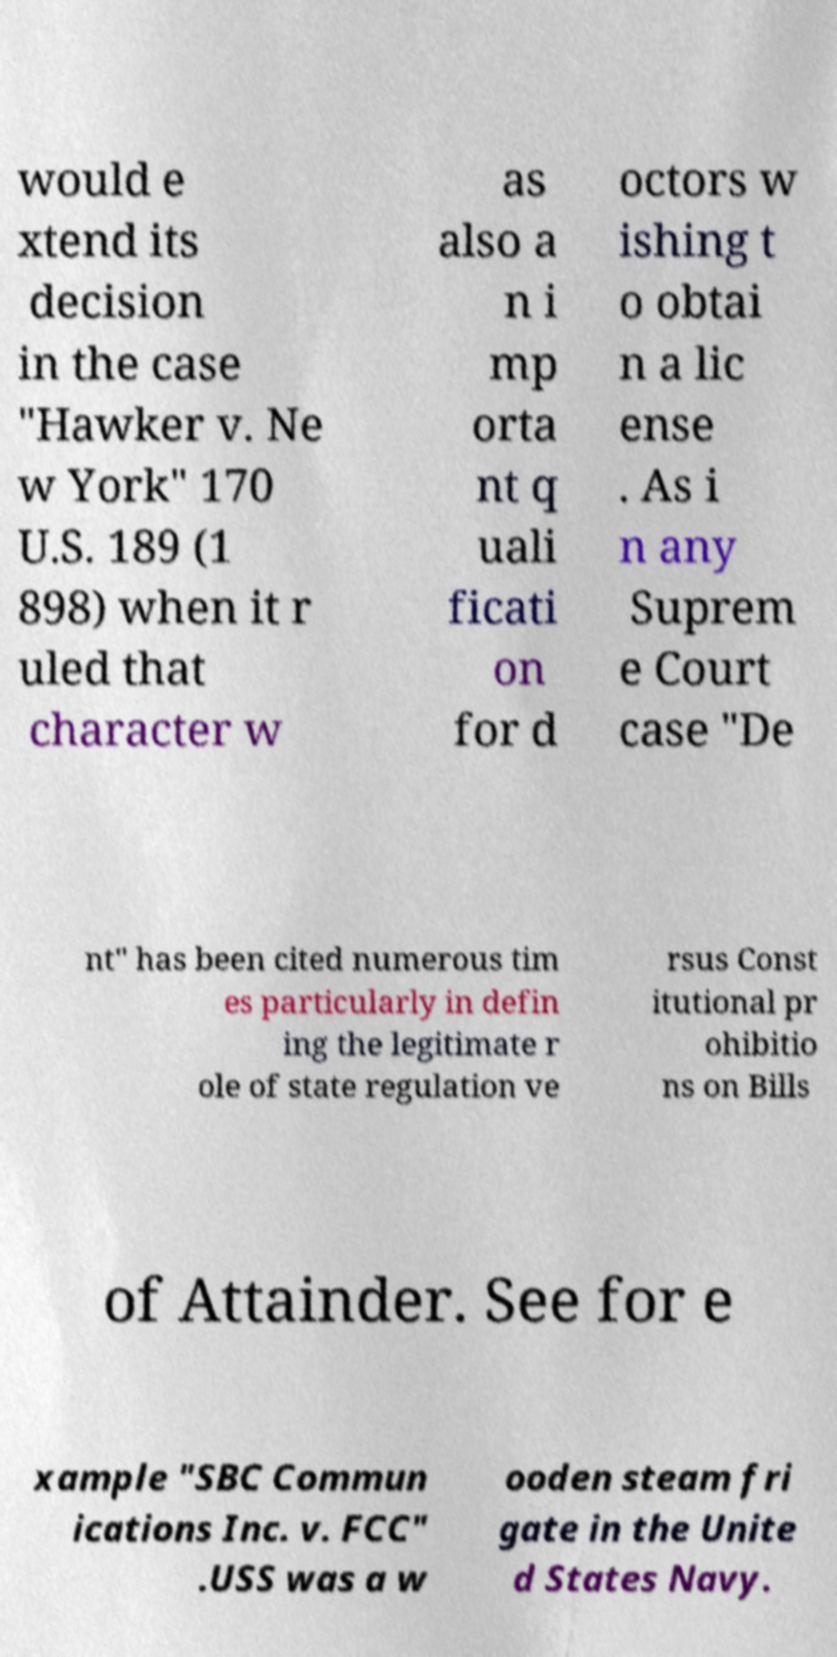Please read and relay the text visible in this image. What does it say? would e xtend its decision in the case "Hawker v. Ne w York" 170 U.S. 189 (1 898) when it r uled that character w as also a n i mp orta nt q uali ficati on for d octors w ishing t o obtai n a lic ense . As i n any Suprem e Court case "De nt" has been cited numerous tim es particularly in defin ing the legitimate r ole of state regulation ve rsus Const itutional pr ohibitio ns on Bills of Attainder. See for e xample "SBC Commun ications Inc. v. FCC" .USS was a w ooden steam fri gate in the Unite d States Navy. 